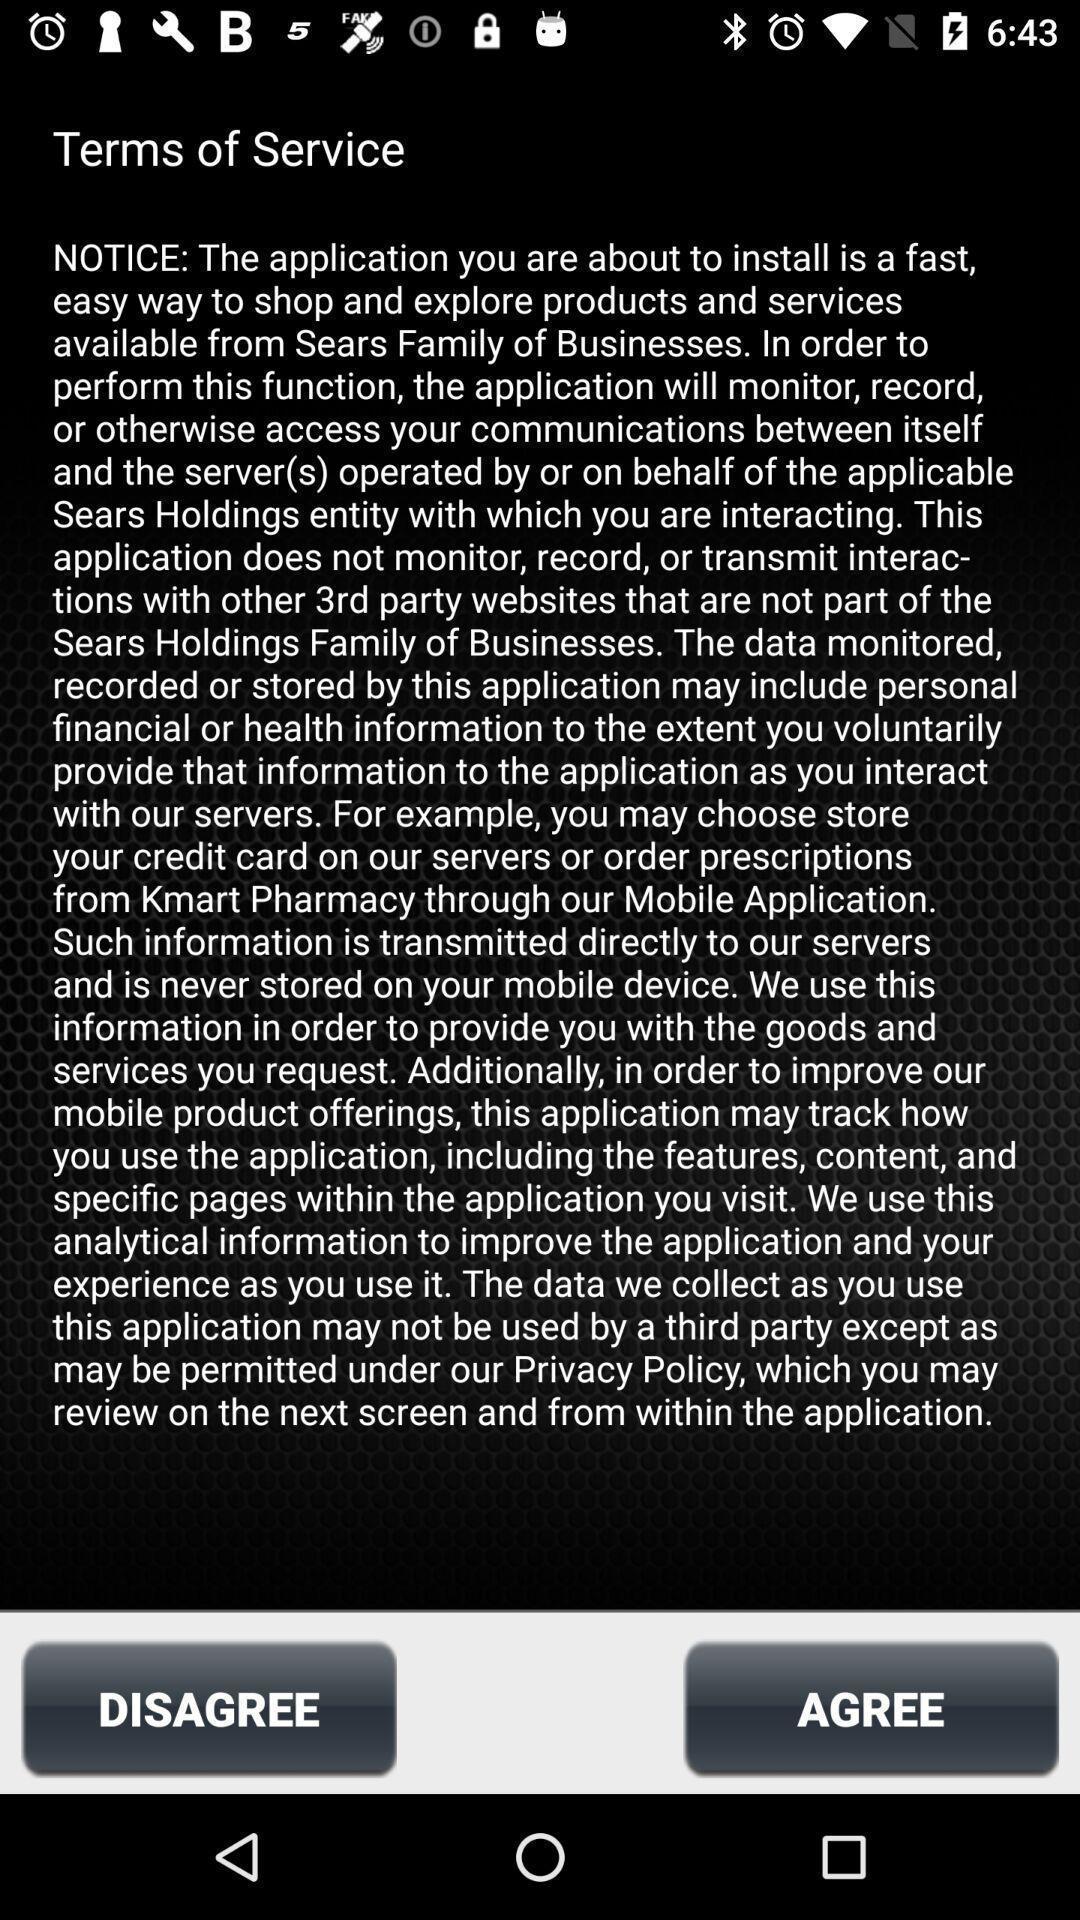Describe the content in this image. Page shows terms of service in service application. 